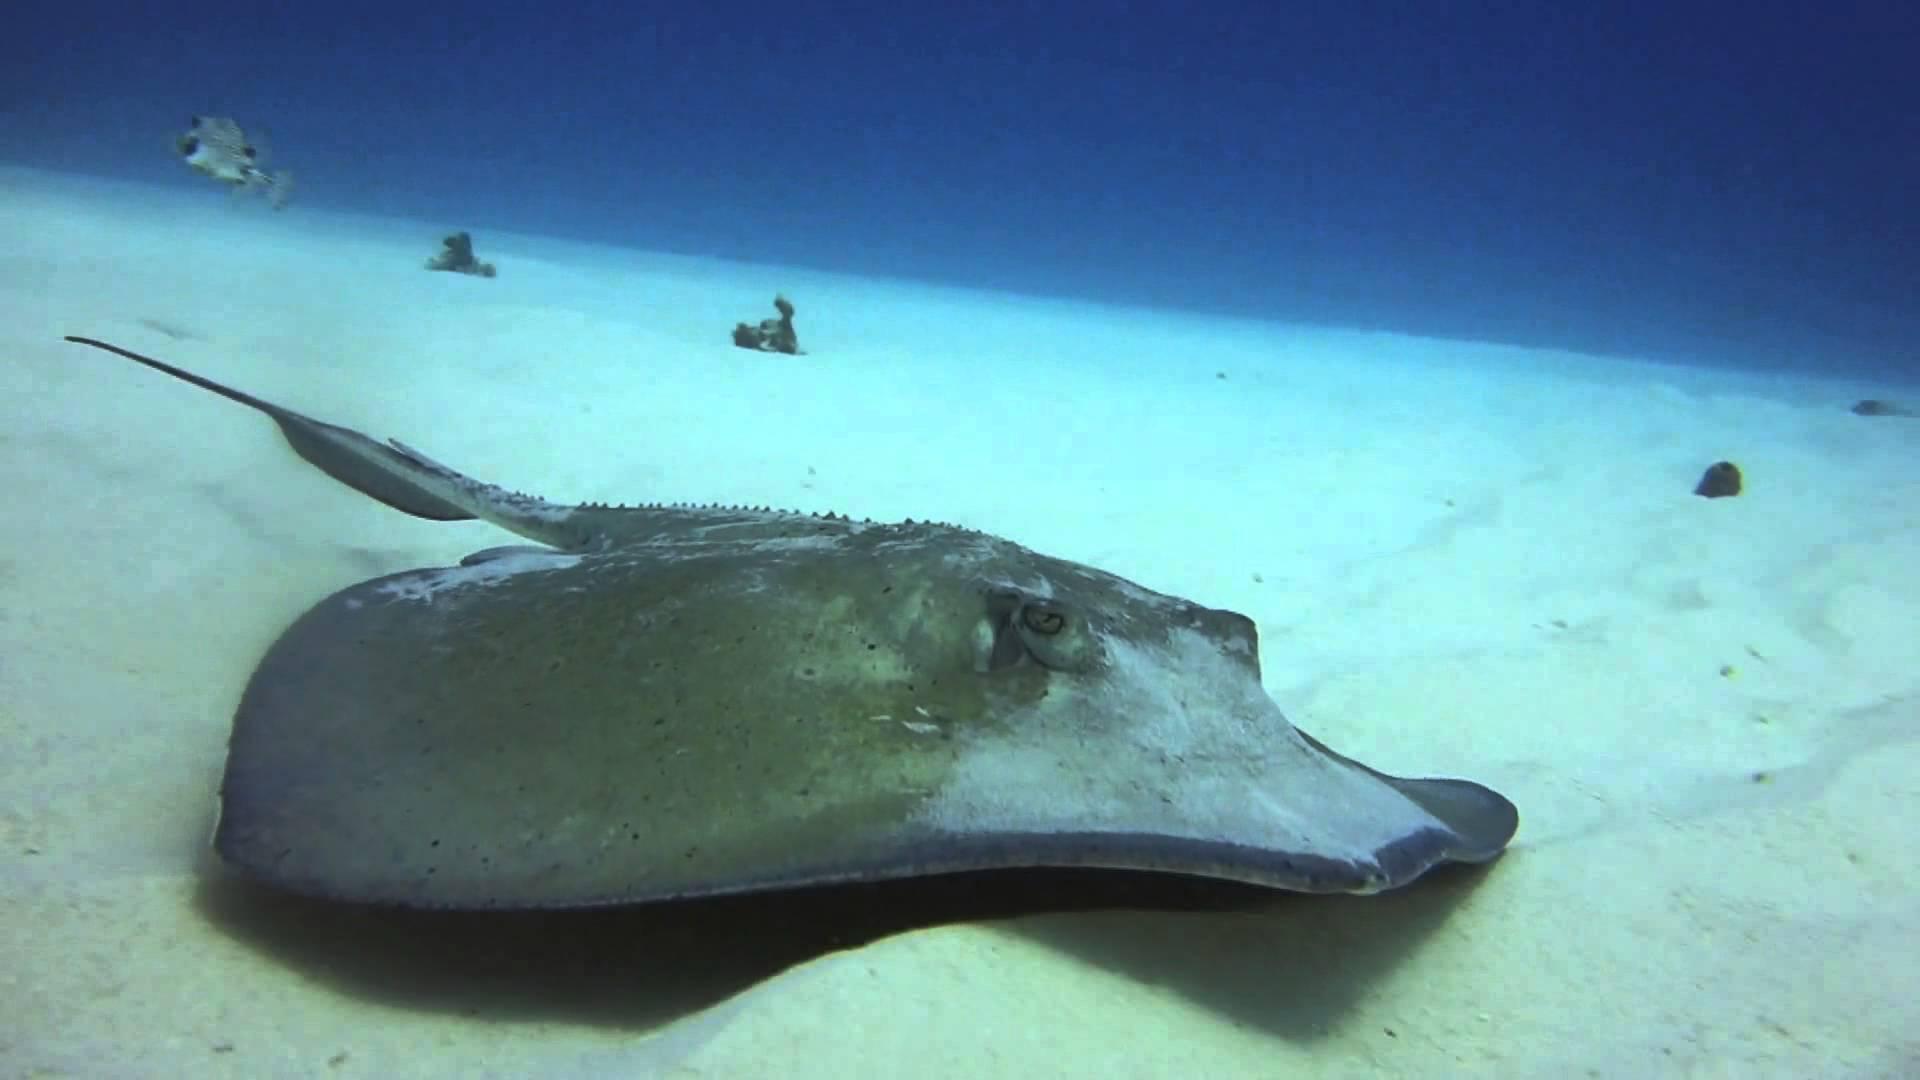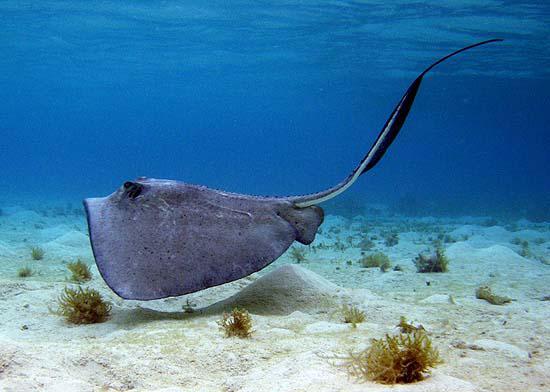The first image is the image on the left, the second image is the image on the right. Analyze the images presented: Is the assertion "In one image, a dark, flat, purple-blue fish has a white underside and a long thin tail." valid? Answer yes or no. Yes. 